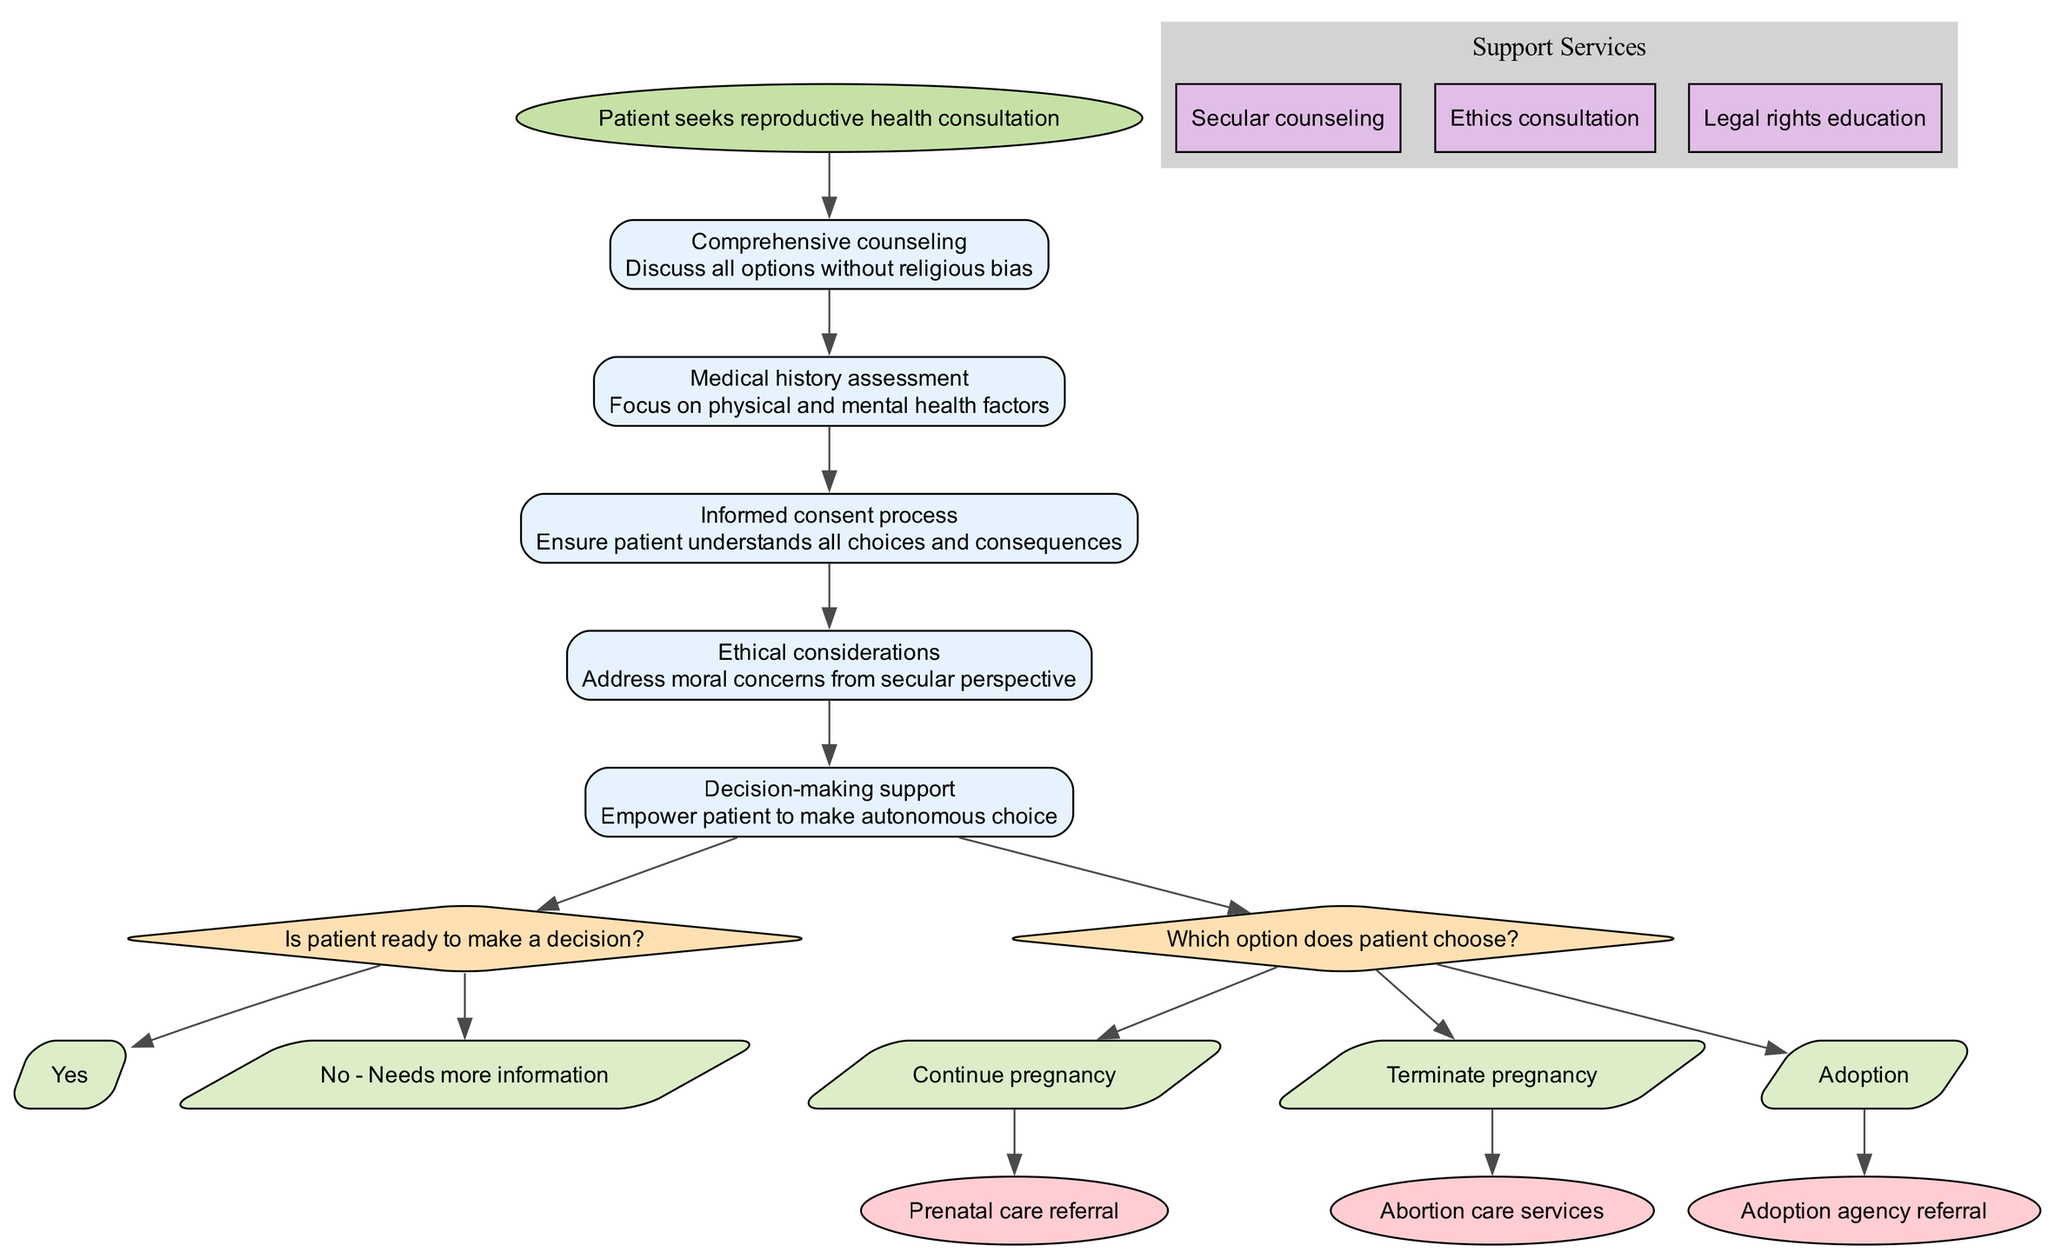What is the starting point of the pathway? The starting point is explicitly labeled in the diagram as "Patient seeks reproductive health consultation." It is the first node from which all subsequent steps and decisions branch out.
Answer: Patient seeks reproductive health consultation How many steps are included in the pathway? By counting the nodes labeled as "steps," we find there are a total of 5 steps outlined in the diagram. They detail the process of consultation.
Answer: 5 What is the last endpoint listed in the pathway? The endpoint is identified within the final nodes, and the last one is "Adoption agency referral," appearing at the end of the decision branches.
Answer: Adoption agency referral What question is asked at the first decision point? The text in the decision point clearly states the question as "Is patient ready to make a decision?" This question facilitates the patient's journey through the pathway.
Answer: Is patient ready to make a decision? Which option follows the decision "Needs more information"? Tracing from the decision node related to "Is patient ready to make a decision?" leads to successive nodes. The specific option that follows this decision is captured directly in its labeled node.
Answer: Needs more information What supports are provided for patients during the process? The support services branch clearly labeled indicates three services, which can be referenced in the diagram. These services directly assist patients throughout the clinical pathway.
Answer: Secular counseling, Ethics consultation, Legal rights education What consequence options are available for the patient after decision-making support? The decision-making support leads to a crucial junction where patients make choices: "Continue pregnancy," "Terminate pregnancy," or "Adoption." Each option is a consequential action stemming from their empowered decision.
Answer: Continue pregnancy, Terminate pregnancy, Adoption Which step emphasizes ethical considerations? The step clearly associated with ethical issues is the one labeled "Ethical considerations." Its placement in the sequence signifies its importance in discussing moral concerns without religious bias.
Answer: Ethical considerations 